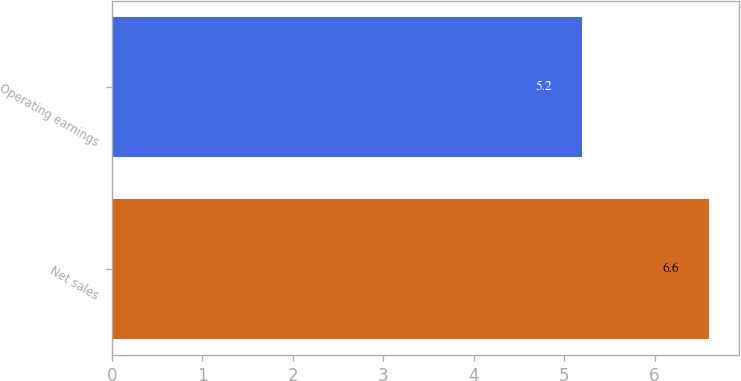Convert chart. <chart><loc_0><loc_0><loc_500><loc_500><bar_chart><fcel>Net sales<fcel>Operating earnings<nl><fcel>6.6<fcel>5.2<nl></chart> 